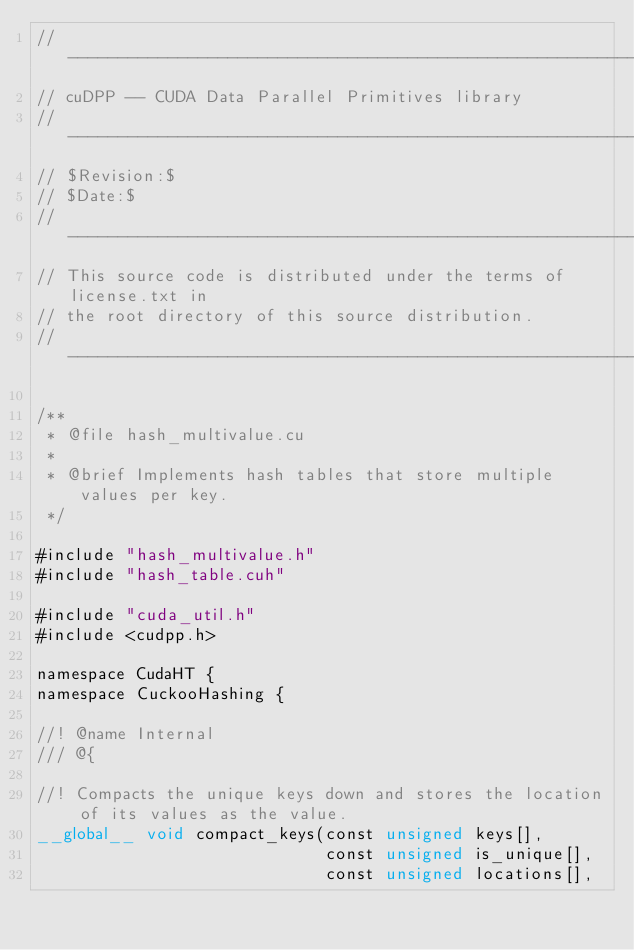Convert code to text. <code><loc_0><loc_0><loc_500><loc_500><_Cuda_>// -------------------------------------------------------------
// cuDPP -- CUDA Data Parallel Primitives library
// -------------------------------------------------------------
// $Revision:$
// $Date:$
// ------------------------------------------------------------- 
// This source code is distributed under the terms of license.txt in
// the root directory of this source distribution.
// ------------------------------------------------------------- 

/**
 * @file hash_multivalue.cu
 *
 * @brief Implements hash tables that store multiple values per key.
 */

#include "hash_multivalue.h"
#include "hash_table.cuh"

#include "cuda_util.h"
#include <cudpp.h>

namespace CudaHT {
namespace CuckooHashing {

//! @name Internal
/// @{

//! Compacts the unique keys down and stores the location of its values as the value.
__global__ void compact_keys(const unsigned keys[],
                             const unsigned is_unique[],
                             const unsigned locations[],</code> 